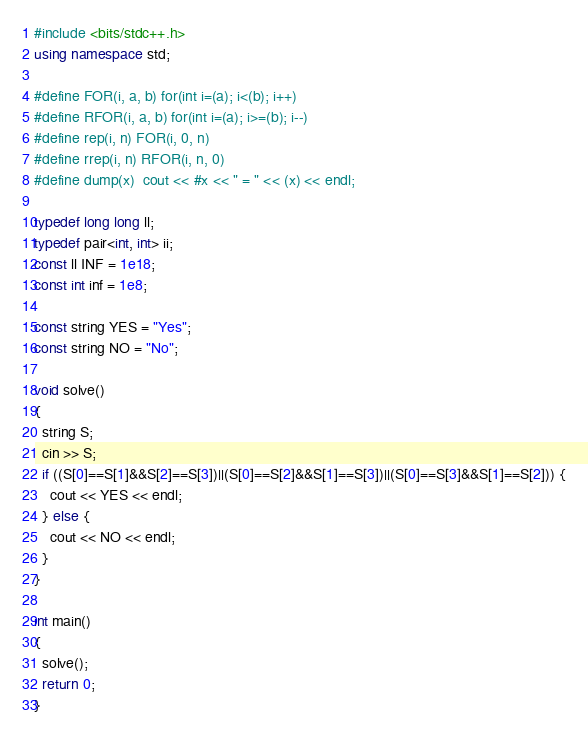Convert code to text. <code><loc_0><loc_0><loc_500><loc_500><_C++_>#include <bits/stdc++.h>
using namespace std;

#define FOR(i, a, b) for(int i=(a); i<(b); i++)
#define RFOR(i, a, b) for(int i=(a); i>=(b); i--)
#define rep(i, n) FOR(i, 0, n)
#define rrep(i, n) RFOR(i, n, 0)
#define dump(x)  cout << #x << " = " << (x) << endl;

typedef long long ll;
typedef pair<int, int> ii;
const ll INF = 1e18;
const int inf = 1e8;

const string YES = "Yes";
const string NO = "No";

void solve()
{
  string S;
  cin >> S;
  if ((S[0]==S[1]&&S[2]==S[3])||(S[0]==S[2]&&S[1]==S[3])||(S[0]==S[3]&&S[1]==S[2])) {
    cout << YES << endl;
  } else {
    cout << NO << endl;
  }
}

int main()
{
  solve();
  return 0;
}
</code> 